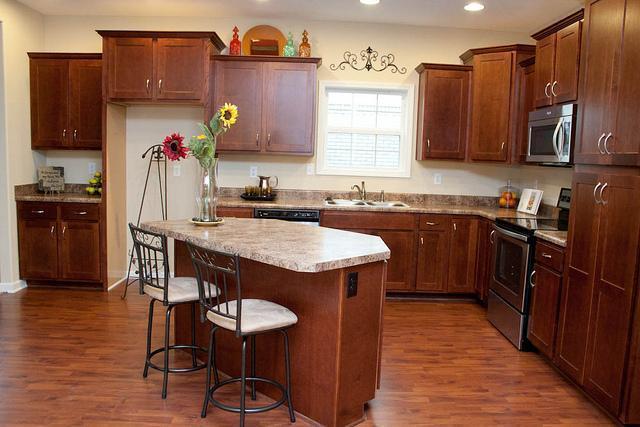How many chairs can be seen?
Give a very brief answer. 2. How many ovens are there?
Give a very brief answer. 1. 